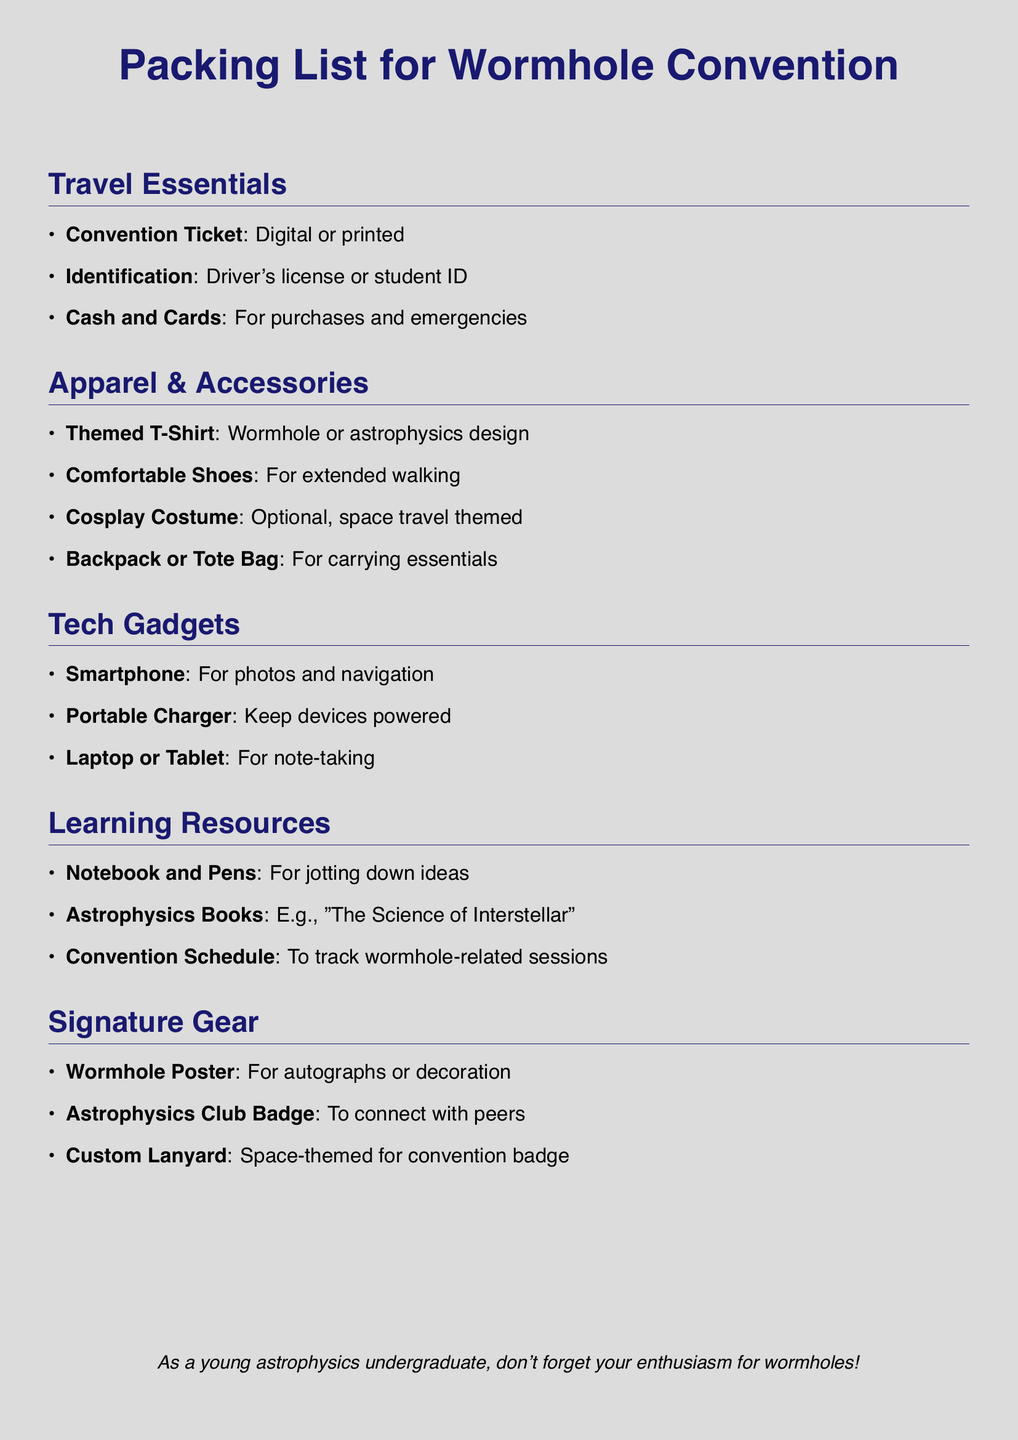What is the title of the document? The title appears at the top of the document and states the focus of the packing list.
Answer: Packing List for Wormhole Convention What type of shoes are recommended? The recommended footwear for comfort during the convention is mentioned in the apparel section.
Answer: Comfortable Shoes What should one bring for note-taking? The document specifies learning resources that include items for jotting down notes.
Answer: Notebook and Pens How many categories are there in the packing list? The document organizes items into distinct sections, which can be counted.
Answer: Five What is suggested for carrying essentials? The document lists an item that is suggested for carrying important items throughout the event.
Answer: Backpack or Tote Bag Which book is specifically mentioned in the learning resources? The document provides an example of a book related to astrophysics included in the learning resources.
Answer: The Science of Interstellar What badge is mentioned for connecting with peers? Among the signature gear, a specific type of badge is suggested for networking.
Answer: Astrophysics Club Badge What type of charger should be brought? The tech gadgets section contains an item that helps keep devices operational.
Answer: Portable Charger What color theme is used for the document's background? The color choice for the document's background is stated and can be identified.
Answer: Stardust 